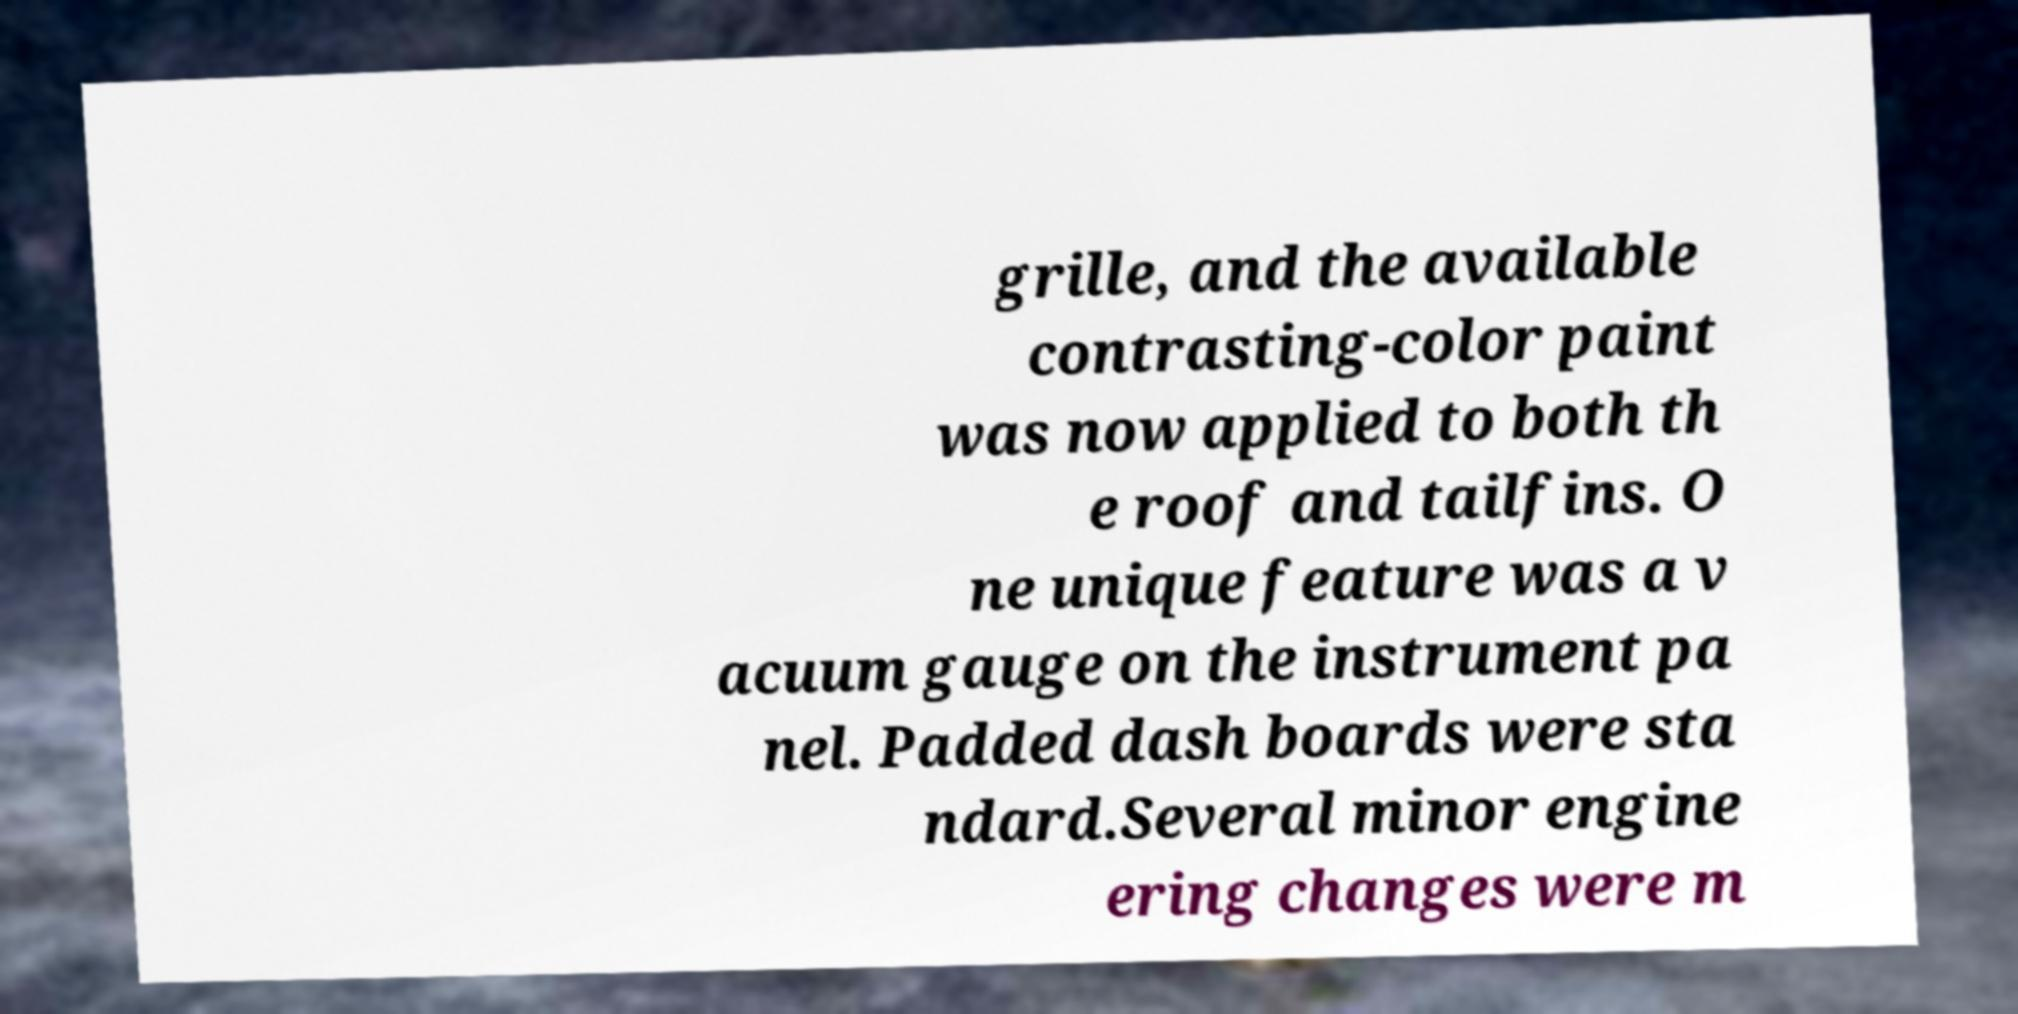Please read and relay the text visible in this image. What does it say? grille, and the available contrasting-color paint was now applied to both th e roof and tailfins. O ne unique feature was a v acuum gauge on the instrument pa nel. Padded dash boards were sta ndard.Several minor engine ering changes were m 